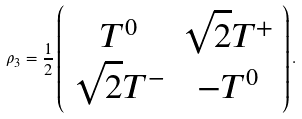<formula> <loc_0><loc_0><loc_500><loc_500>\rho _ { 3 } = \frac { 1 } { 2 } \left ( \begin{array} { c c } T ^ { 0 } & \sqrt { 2 } T ^ { + } \\ \sqrt { 2 } T ^ { - } & - T ^ { 0 } \end{array} \right ) .</formula> 